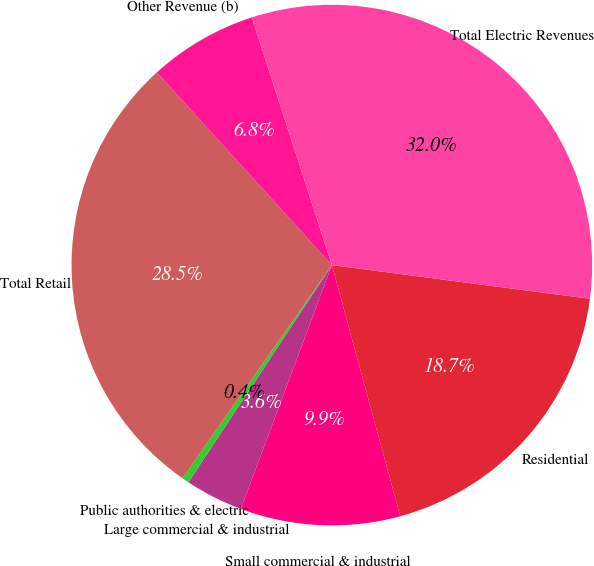Convert chart. <chart><loc_0><loc_0><loc_500><loc_500><pie_chart><fcel>Residential<fcel>Small commercial & industrial<fcel>Large commercial & industrial<fcel>Public authorities & electric<fcel>Total Retail<fcel>Other Revenue (b)<fcel>Total Electric Revenues<nl><fcel>18.7%<fcel>9.92%<fcel>3.6%<fcel>0.44%<fcel>28.53%<fcel>6.76%<fcel>32.04%<nl></chart> 